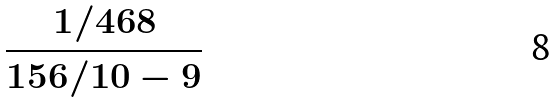Convert formula to latex. <formula><loc_0><loc_0><loc_500><loc_500>\frac { 1 / 4 6 8 } { 1 5 6 / 1 0 - 9 }</formula> 